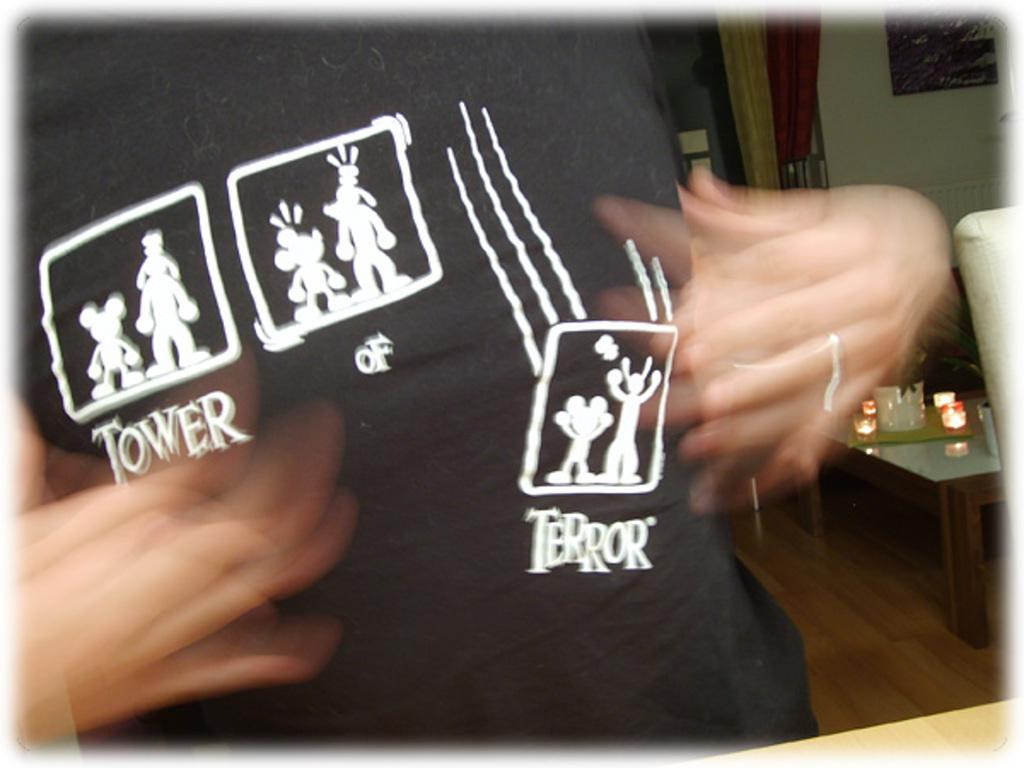What is the person in the image wearing? The person is wearing a black T-shirt. What can be seen on the teapot in the image? There are objects on the teapot in the image. What is attached to the wall in the image? There is a frame attached to the wall in the image. What type of cheese is being used as a reason for the person's actions in the image? There is no cheese or reason for the person's actions mentioned in the image. The person is simply standing there, wearing a black T-shirt. 